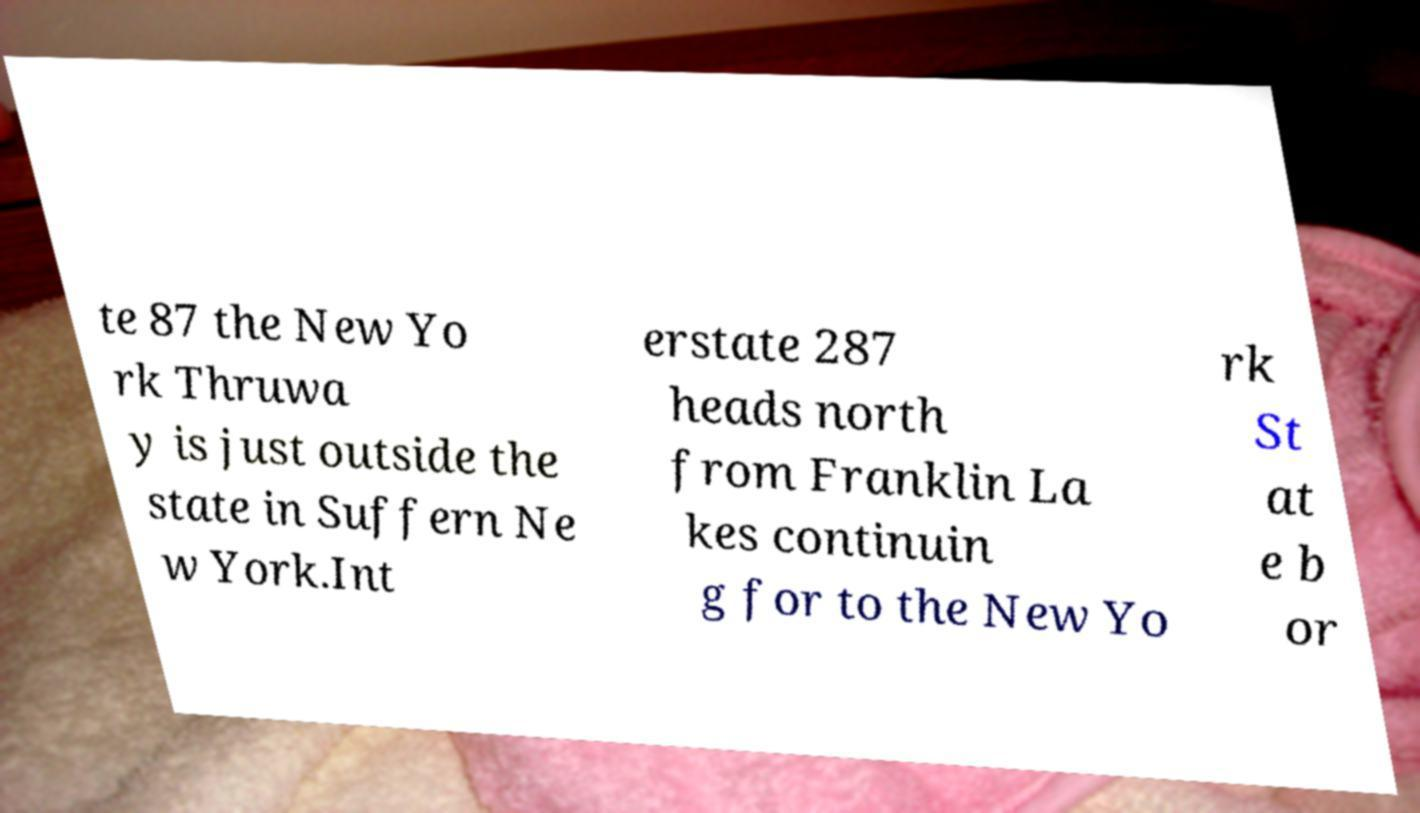What messages or text are displayed in this image? I need them in a readable, typed format. te 87 the New Yo rk Thruwa y is just outside the state in Suffern Ne w York.Int erstate 287 heads north from Franklin La kes continuin g for to the New Yo rk St at e b or 